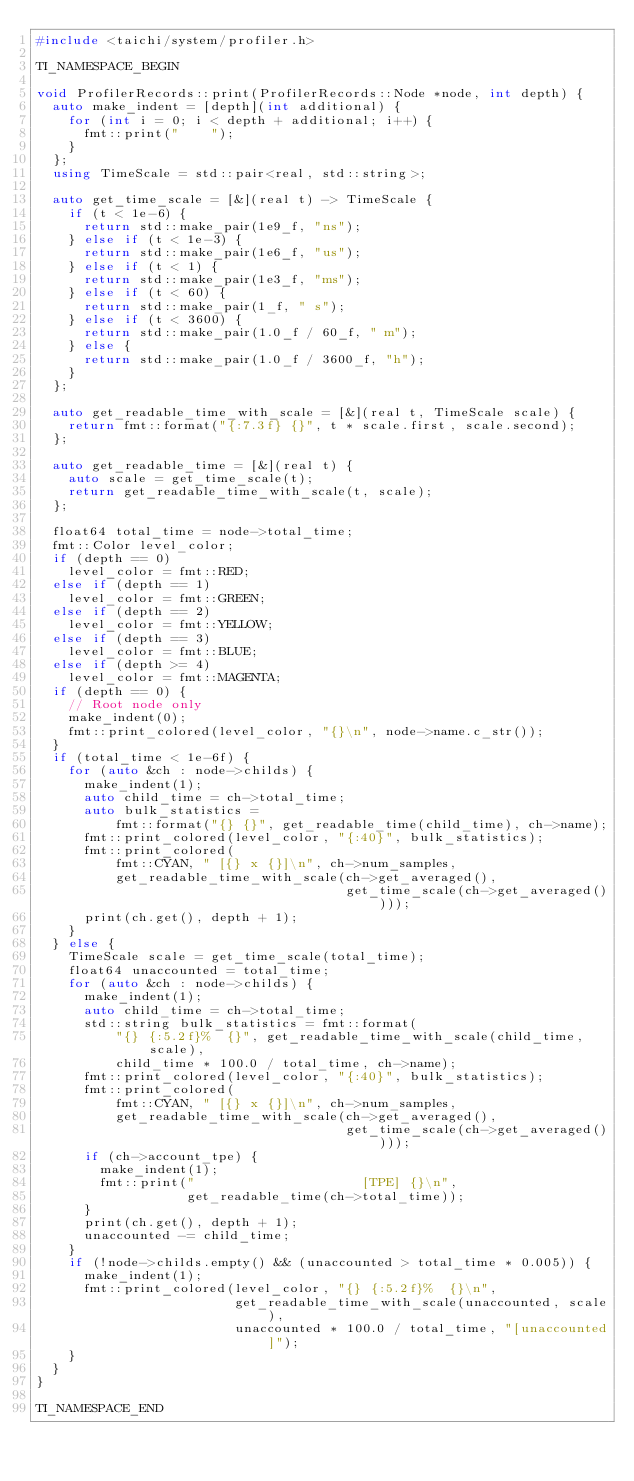<code> <loc_0><loc_0><loc_500><loc_500><_C++_>#include <taichi/system/profiler.h>

TI_NAMESPACE_BEGIN

void ProfilerRecords::print(ProfilerRecords::Node *node, int depth) {
  auto make_indent = [depth](int additional) {
    for (int i = 0; i < depth + additional; i++) {
      fmt::print("    ");
    }
  };
  using TimeScale = std::pair<real, std::string>;

  auto get_time_scale = [&](real t) -> TimeScale {
    if (t < 1e-6) {
      return std::make_pair(1e9_f, "ns");
    } else if (t < 1e-3) {
      return std::make_pair(1e6_f, "us");
    } else if (t < 1) {
      return std::make_pair(1e3_f, "ms");
    } else if (t < 60) {
      return std::make_pair(1_f, " s");
    } else if (t < 3600) {
      return std::make_pair(1.0_f / 60_f, " m");
    } else {
      return std::make_pair(1.0_f / 3600_f, "h");
    }
  };

  auto get_readable_time_with_scale = [&](real t, TimeScale scale) {
    return fmt::format("{:7.3f} {}", t * scale.first, scale.second);
  };

  auto get_readable_time = [&](real t) {
    auto scale = get_time_scale(t);
    return get_readable_time_with_scale(t, scale);
  };

  float64 total_time = node->total_time;
  fmt::Color level_color;
  if (depth == 0)
    level_color = fmt::RED;
  else if (depth == 1)
    level_color = fmt::GREEN;
  else if (depth == 2)
    level_color = fmt::YELLOW;
  else if (depth == 3)
    level_color = fmt::BLUE;
  else if (depth >= 4)
    level_color = fmt::MAGENTA;
  if (depth == 0) {
    // Root node only
    make_indent(0);
    fmt::print_colored(level_color, "{}\n", node->name.c_str());
  }
  if (total_time < 1e-6f) {
    for (auto &ch : node->childs) {
      make_indent(1);
      auto child_time = ch->total_time;
      auto bulk_statistics =
          fmt::format("{} {}", get_readable_time(child_time), ch->name);
      fmt::print_colored(level_color, "{:40}", bulk_statistics);
      fmt::print_colored(
          fmt::CYAN, " [{} x {}]\n", ch->num_samples,
          get_readable_time_with_scale(ch->get_averaged(),
                                       get_time_scale(ch->get_averaged())));
      print(ch.get(), depth + 1);
    }
  } else {
    TimeScale scale = get_time_scale(total_time);
    float64 unaccounted = total_time;
    for (auto &ch : node->childs) {
      make_indent(1);
      auto child_time = ch->total_time;
      std::string bulk_statistics = fmt::format(
          "{} {:5.2f}%  {}", get_readable_time_with_scale(child_time, scale),
          child_time * 100.0 / total_time, ch->name);
      fmt::print_colored(level_color, "{:40}", bulk_statistics);
      fmt::print_colored(
          fmt::CYAN, " [{} x {}]\n", ch->num_samples,
          get_readable_time_with_scale(ch->get_averaged(),
                                       get_time_scale(ch->get_averaged())));
      if (ch->account_tpe) {
        make_indent(1);
        fmt::print("                     [TPE] {}\n",
                   get_readable_time(ch->total_time));
      }
      print(ch.get(), depth + 1);
      unaccounted -= child_time;
    }
    if (!node->childs.empty() && (unaccounted > total_time * 0.005)) {
      make_indent(1);
      fmt::print_colored(level_color, "{} {:5.2f}%  {}\n",
                         get_readable_time_with_scale(unaccounted, scale),
                         unaccounted * 100.0 / total_time, "[unaccounted]");
    }
  }
}

TI_NAMESPACE_END
</code> 